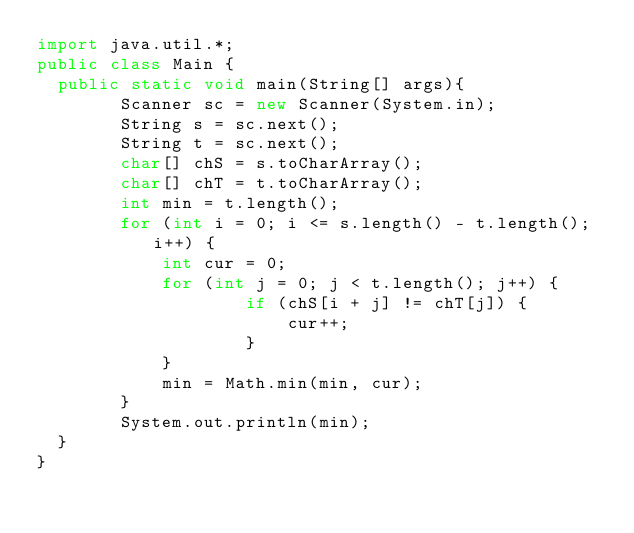Convert code to text. <code><loc_0><loc_0><loc_500><loc_500><_Java_>import java.util.*;
public class Main {
	public static void main(String[] args){
        Scanner sc = new Scanner(System.in);
        String s = sc.next();
        String t = sc.next();
        char[] chS = s.toCharArray();
        char[] chT = t.toCharArray();
        int min = t.length(); 
        for (int i = 0; i <= s.length() - t.length(); i++) {
            int cur = 0; 
            for (int j = 0; j < t.length(); j++) {
                    if (chS[i + j] != chT[j]) {
                        cur++;
                    } 
            }
            min = Math.min(min, cur);
        }
        System.out.println(min);
	}
}</code> 